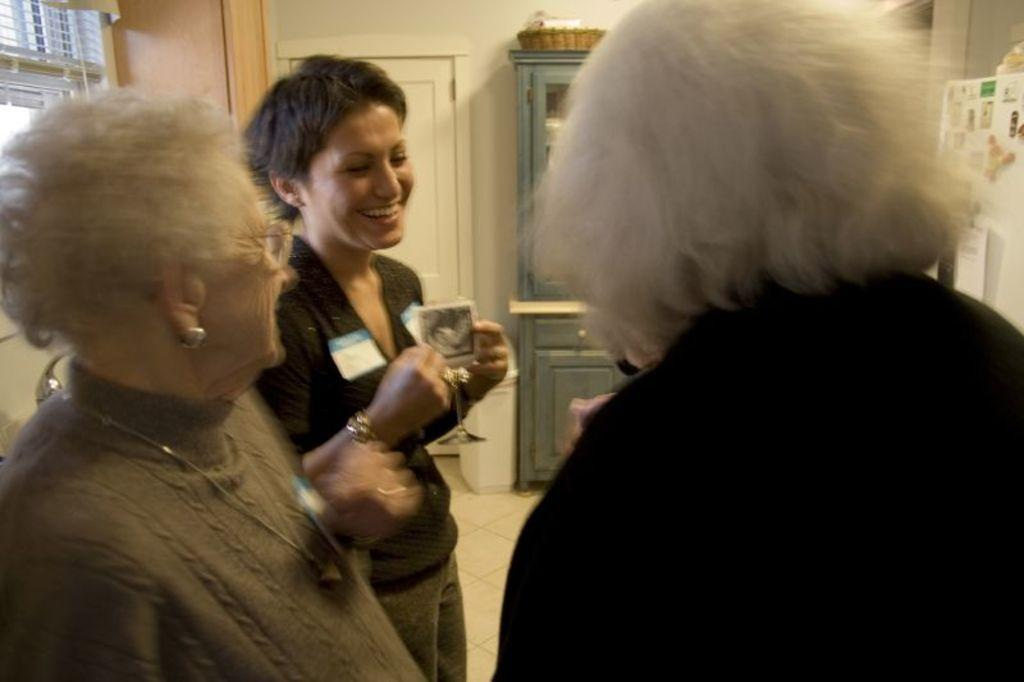How many women are present in the image? There are three women in the image. What are the women doing in the image? The women are standing on the floor. Can you describe the actions of one of the women? One of the women is holding a glass. What can be seen in the background of the image? There is a window, a curtain, a door, a wall, and a basket on a cupboard in the background of the image. What fact can be seen in the image about the women's feelings towards each other? There is no information about the women's feelings towards each other in the image. Can you describe the drawer in the image? There is no drawer present in the image. 